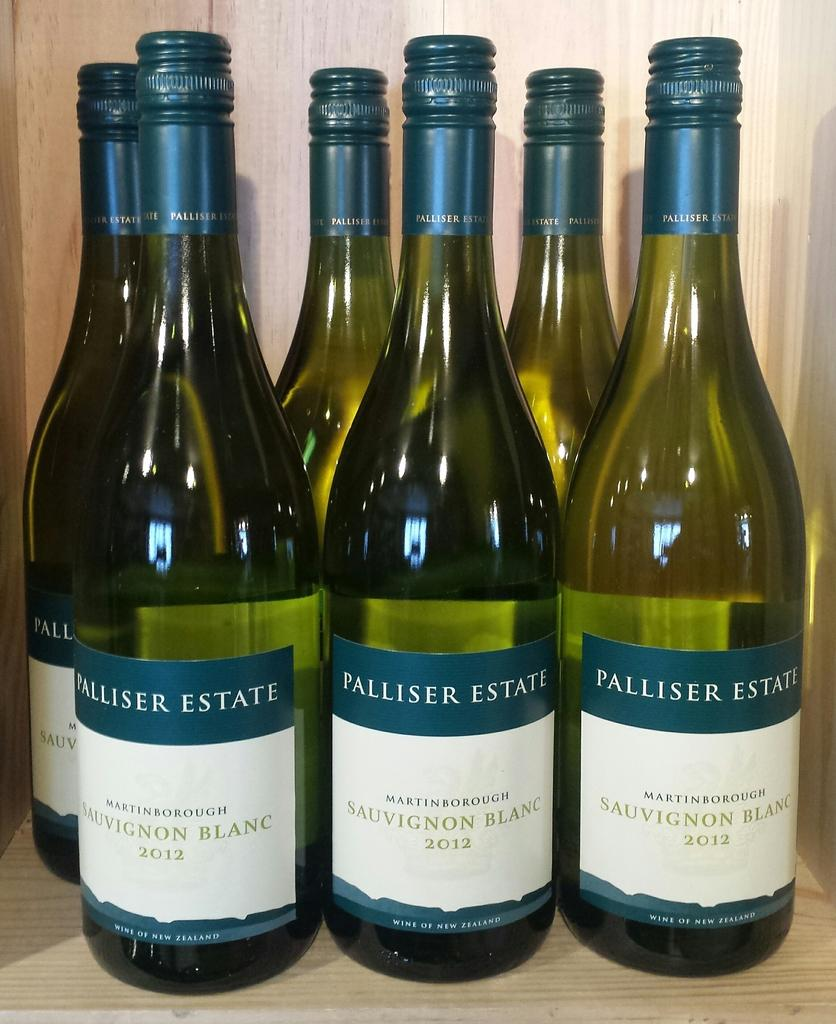Provide a one-sentence caption for the provided image. Several bottles of wine from the Palliser Estate brand with the variety Sauvignon Blanc written on their labels. 